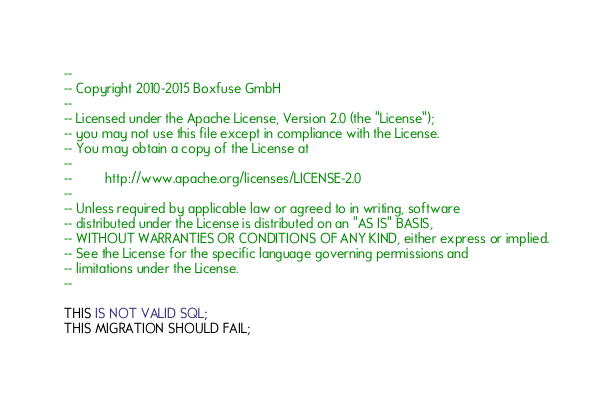Convert code to text. <code><loc_0><loc_0><loc_500><loc_500><_SQL_>--
-- Copyright 2010-2015 Boxfuse GmbH
--
-- Licensed under the Apache License, Version 2.0 (the "License");
-- you may not use this file except in compliance with the License.
-- You may obtain a copy of the License at
--
--         http://www.apache.org/licenses/LICENSE-2.0
--
-- Unless required by applicable law or agreed to in writing, software
-- distributed under the License is distributed on an "AS IS" BASIS,
-- WITHOUT WARRANTIES OR CONDITIONS OF ANY KIND, either express or implied.
-- See the License for the specific language governing permissions and
-- limitations under the License.
--

THIS IS NOT VALID SQL;
THIS MIGRATION SHOULD FAIL;</code> 